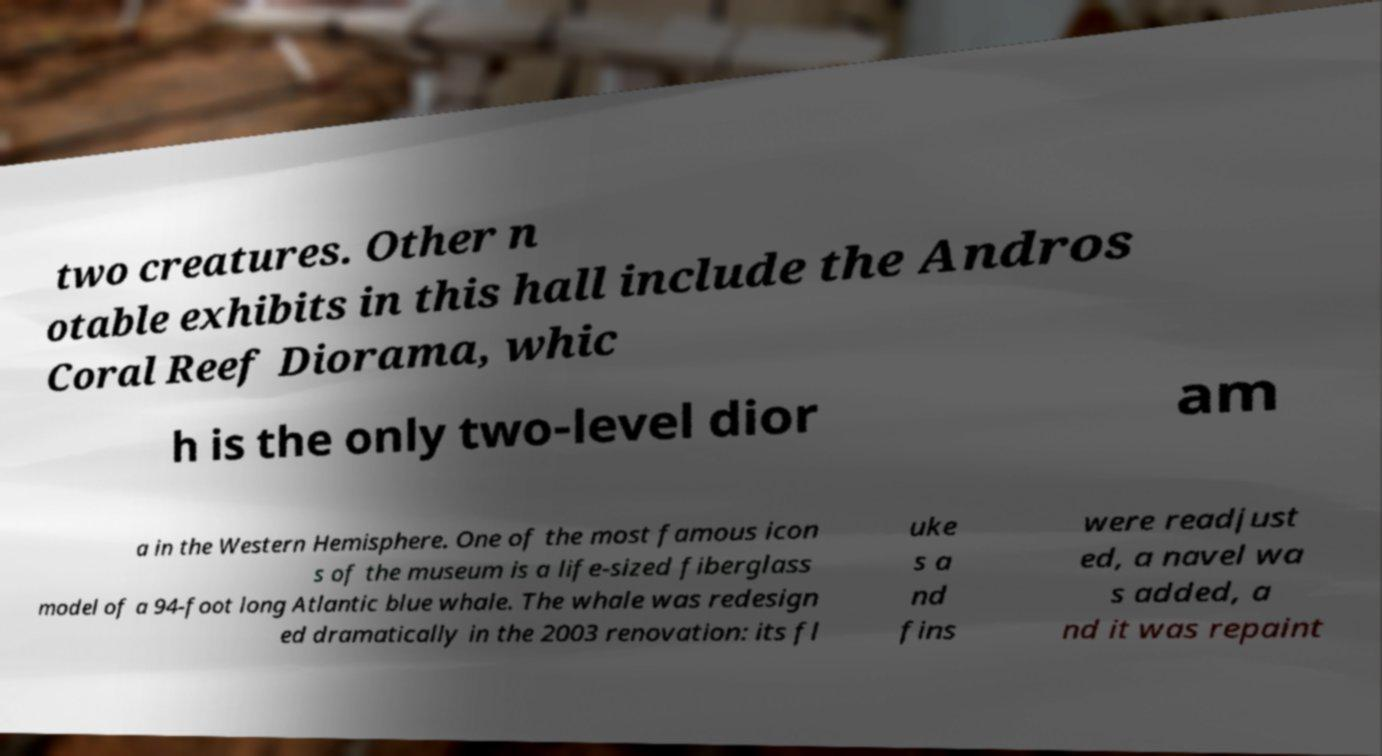I need the written content from this picture converted into text. Can you do that? two creatures. Other n otable exhibits in this hall include the Andros Coral Reef Diorama, whic h is the only two-level dior am a in the Western Hemisphere. One of the most famous icon s of the museum is a life-sized fiberglass model of a 94-foot long Atlantic blue whale. The whale was redesign ed dramatically in the 2003 renovation: its fl uke s a nd fins were readjust ed, a navel wa s added, a nd it was repaint 